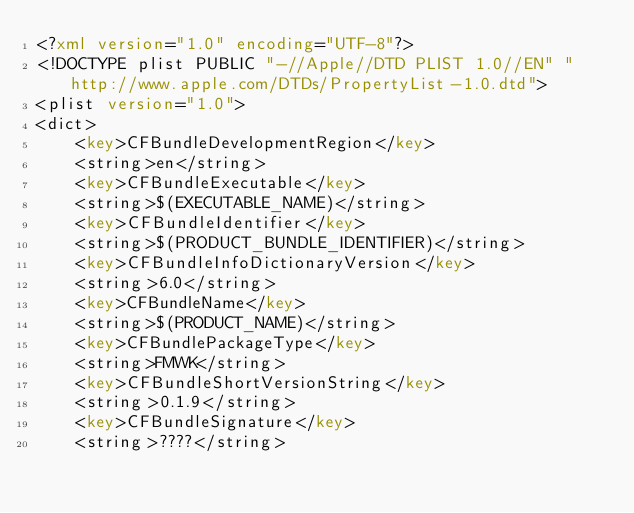<code> <loc_0><loc_0><loc_500><loc_500><_XML_><?xml version="1.0" encoding="UTF-8"?>
<!DOCTYPE plist PUBLIC "-//Apple//DTD PLIST 1.0//EN" "http://www.apple.com/DTDs/PropertyList-1.0.dtd">
<plist version="1.0">
<dict>
	<key>CFBundleDevelopmentRegion</key>
	<string>en</string>
	<key>CFBundleExecutable</key>
	<string>$(EXECUTABLE_NAME)</string>
	<key>CFBundleIdentifier</key>
	<string>$(PRODUCT_BUNDLE_IDENTIFIER)</string>
	<key>CFBundleInfoDictionaryVersion</key>
	<string>6.0</string>
	<key>CFBundleName</key>
	<string>$(PRODUCT_NAME)</string>
	<key>CFBundlePackageType</key>
	<string>FMWK</string>
	<key>CFBundleShortVersionString</key>
	<string>0.1.9</string>
	<key>CFBundleSignature</key>
	<string>????</string></code> 